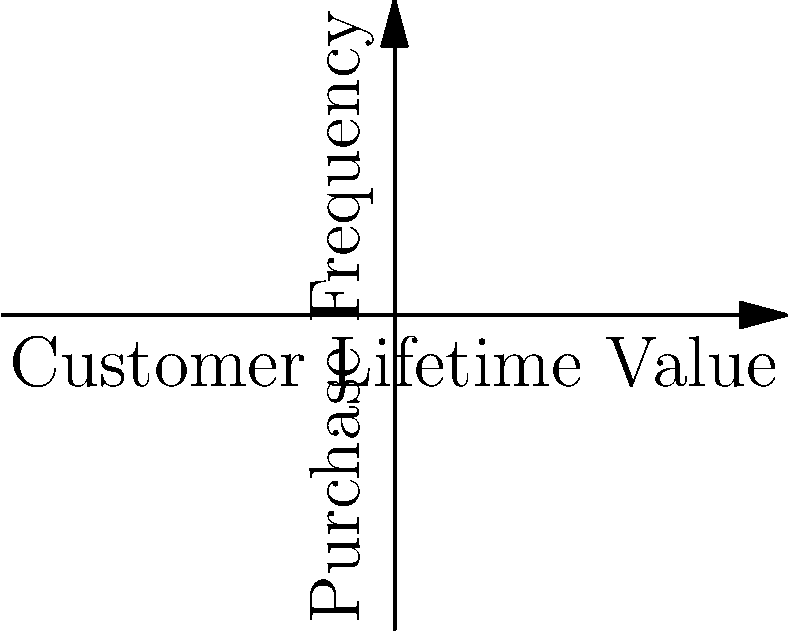As a successful business owner, you're analyzing customer segmentation data. The scatter plot shows customer segments based on Lifetime Value and Purchase Frequency. Which segment appears to have the highest potential for increased investment and targeted marketing strategies to maximize ROI? To determine the segment with the highest potential for increased investment and targeted marketing strategies, we need to analyze the scatter plot:

1. Identify the segments:
   - Segment A (red): Low Lifetime Value, Low Purchase Frequency
   - Segment B (green): Medium Lifetime Value, Medium Purchase Frequency
   - Segment C (blue): High Lifetime Value, High Purchase Frequency

2. Assess the characteristics of each segment:
   - Segment A: These customers have low engagement and low value. They might be new or infrequent customers.
   - Segment B: These customers show moderate engagement and value. They have potential for growth.
   - Segment C: These customers demonstrate high engagement and high value. They are likely loyal customers.

3. Consider the potential for increased ROI:
   - Segment A: High effort might be required to increase their value, with uncertain returns.
   - Segment B: Moderate effort could yield significant improvements in both frequency and value.
   - Segment C: These customers are already high-value, so incremental gains might be smaller but more certain.

4. Evaluate the risk-reward ratio:
   - Segment C has the lowest risk as these customers are already valuable.
   - Segment B has a balanced risk-reward profile with good potential for growth.
   - Segment A has the highest risk but potentially high rewards if successfully converted.

5. Consider the investor perspective:
   - Investors typically prefer strategies that balance growth potential with existing value.
   - Segment B offers the best opportunity to demonstrate both customer base expansion and value increase.

Based on this analysis, Segment B appears to have the highest potential for increased investment and targeted marketing strategies to maximize ROI. It offers a good balance of existing value and growth potential, which is attractive to investors and aligns with efficient use of marketing resources.
Answer: Segment B 